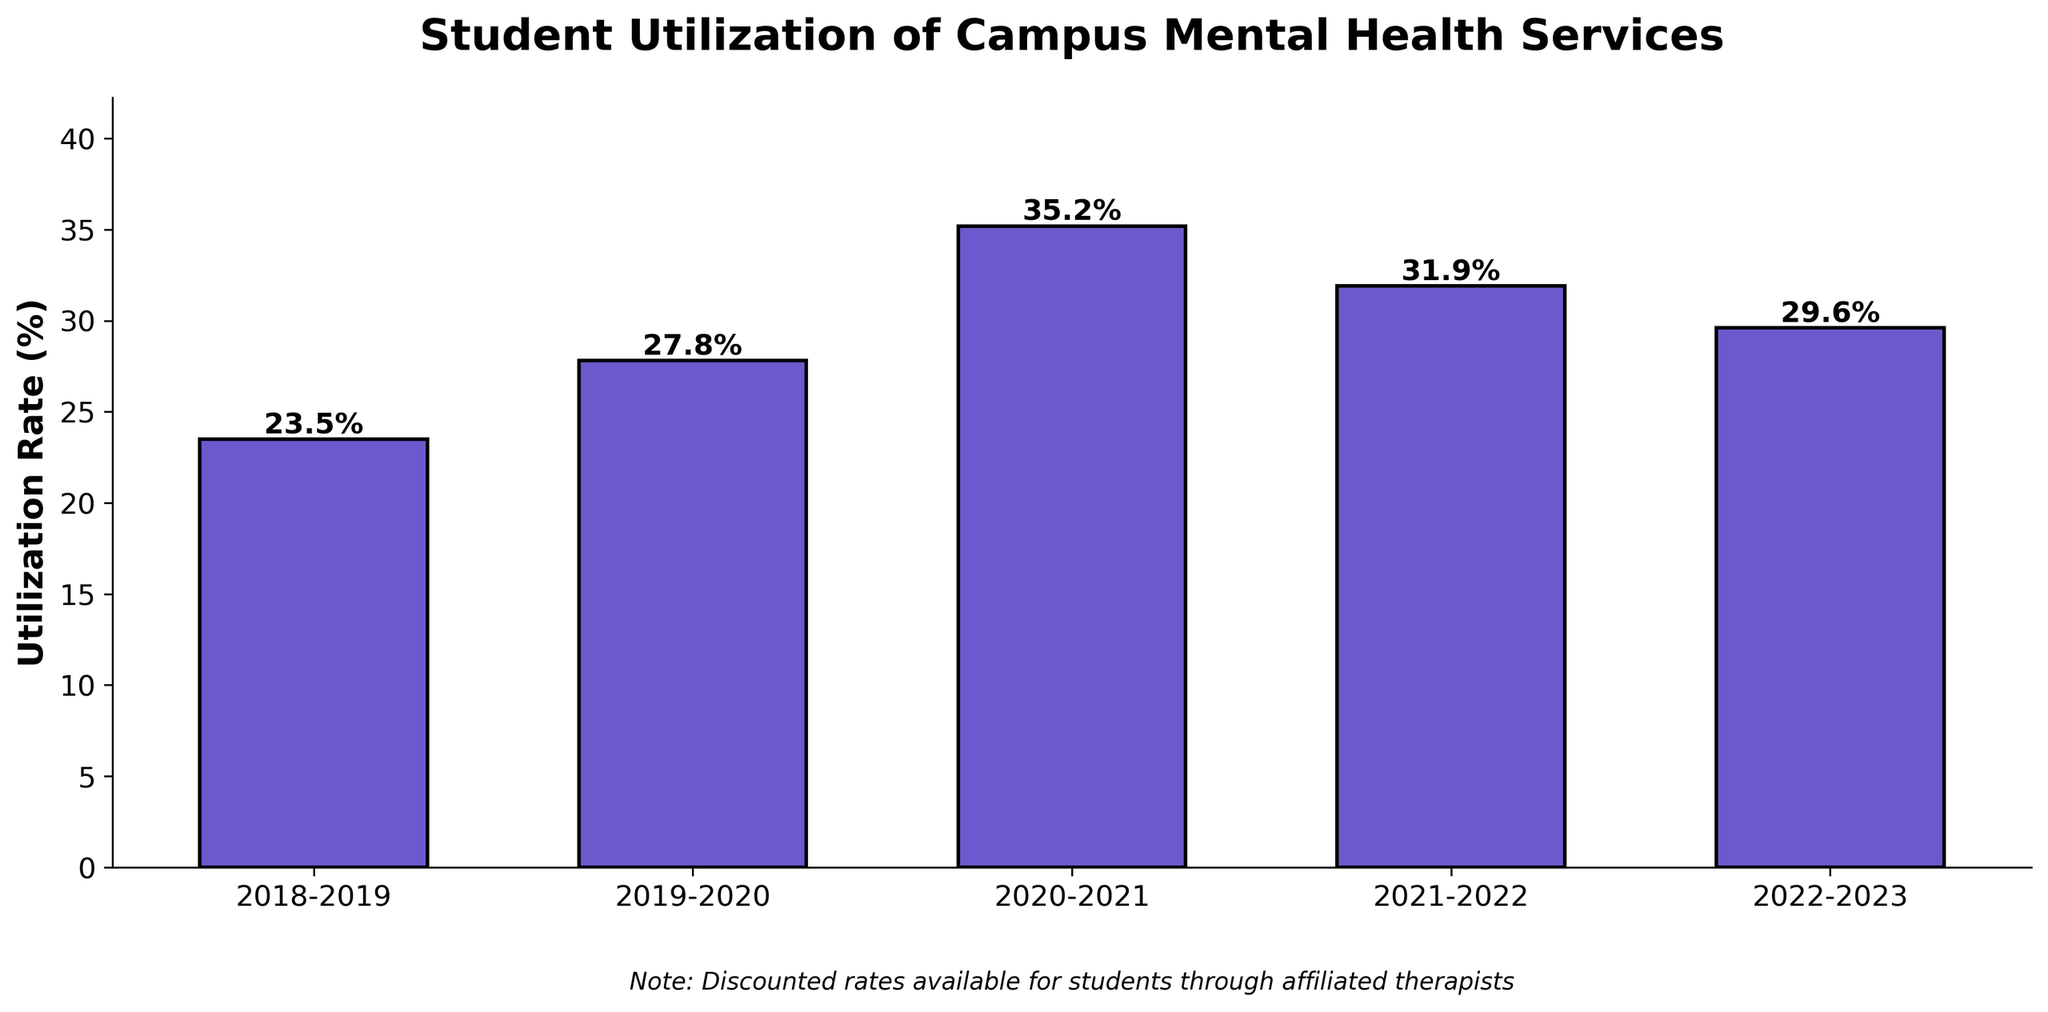What is the utilization rate for the academic year 2020-2021? The bar labeled 2020-2021 shows a height, and the value on top of the bar indicates the utilization rate. Looking at the figure, it shows 35.2%.
Answer: 35.2% Which academic year saw the highest utilization rate of campus mental health services? By comparing the heights of all the bars, the one for 2020-2021 is the tallest with a value of 35.2%.
Answer: 2020-2021 What is the difference in utilization rate between the highest and lowest academic years? The highest utilization rate is 35.2% (2020-2021). The lowest is 23.5% (2018-2019). The difference is 35.2% - 23.5% = 11.7%.
Answer: 11.7% How did the utilization rate change from 2020-2021 to 2021-2022? The utilization rate for 2020-2021 is 35.2%. For 2021-2022, it is 31.9%. The change is 31.9% - 35.2% = -3.3%. So, it decreased by 3.3%.
Answer: -3.3% Which academic year had a utilization rate closest to 30%? Checking the values on top of each bar, 2022-2023 has a utilization rate of 29.6%, which is the closest to 30%.
Answer: 2022-2023 By how much did the utilization rate increase from the academic year 2018-2019 to 2019-2020? The rate in 2018-2019 is 23.5%, and in 2019-2020 it is 27.8%. The increase is 27.8% - 23.5% = 4.3%.
Answer: 4.3% What is the average utilization rate across the five academic years shown? The rates are 23.5%, 27.8%, 35.2%, 31.9%, and 29.6%. Sum these values: 23.5 + 27.8 + 35.2 + 31.9 + 29.6 = 148. Multiply by 1/n, where n=5: 148 / 5 = 29.6%.
Answer: 29.6% Which academic years had a utilization rate of above 30%? Observing the values on the bars: 2020-2021 (35.2%) and 2021-2022 (31.9%) are above 30%.
Answer: 2020-2021, 2021-2022 